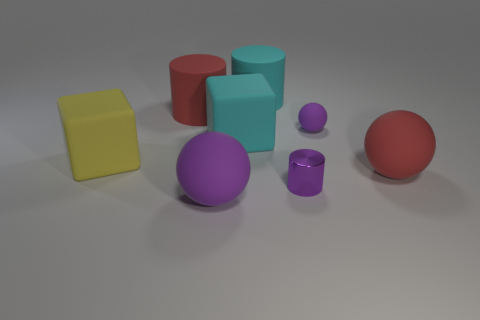What is the size of the cylinder that is the same color as the small sphere?
Your answer should be very brief. Small. What number of other objects are the same shape as the tiny matte thing?
Give a very brief answer. 2. What number of objects are matte things or big yellow matte spheres?
Your response must be concise. 7. What is the size of the purple ball on the left side of the tiny cylinder?
Offer a terse response. Large. There is a thing that is both behind the cyan matte cube and on the right side of the large cyan rubber cylinder; what color is it?
Provide a succinct answer. Purple. Is the material of the thing right of the small purple ball the same as the big cyan cylinder?
Your answer should be very brief. Yes. There is a tiny cylinder; is it the same color as the big ball to the right of the purple shiny cylinder?
Provide a short and direct response. No. Are there any big red rubber things on the right side of the purple cylinder?
Your answer should be very brief. Yes. There is a purple thing behind the cyan block; is its size the same as the cylinder that is in front of the large red rubber sphere?
Offer a very short reply. Yes. Is there a shiny object of the same size as the yellow block?
Keep it short and to the point. No. 